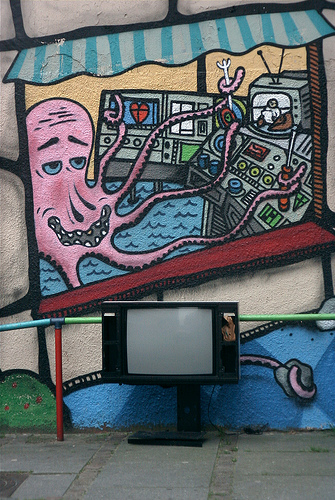<image>
Is there a octopus above the tv? Yes. The octopus is positioned above the tv in the vertical space, higher up in the scene. Is there a octopus on the tv? No. The octopus is not positioned on the tv. They may be near each other, but the octopus is not supported by or resting on top of the tv. 